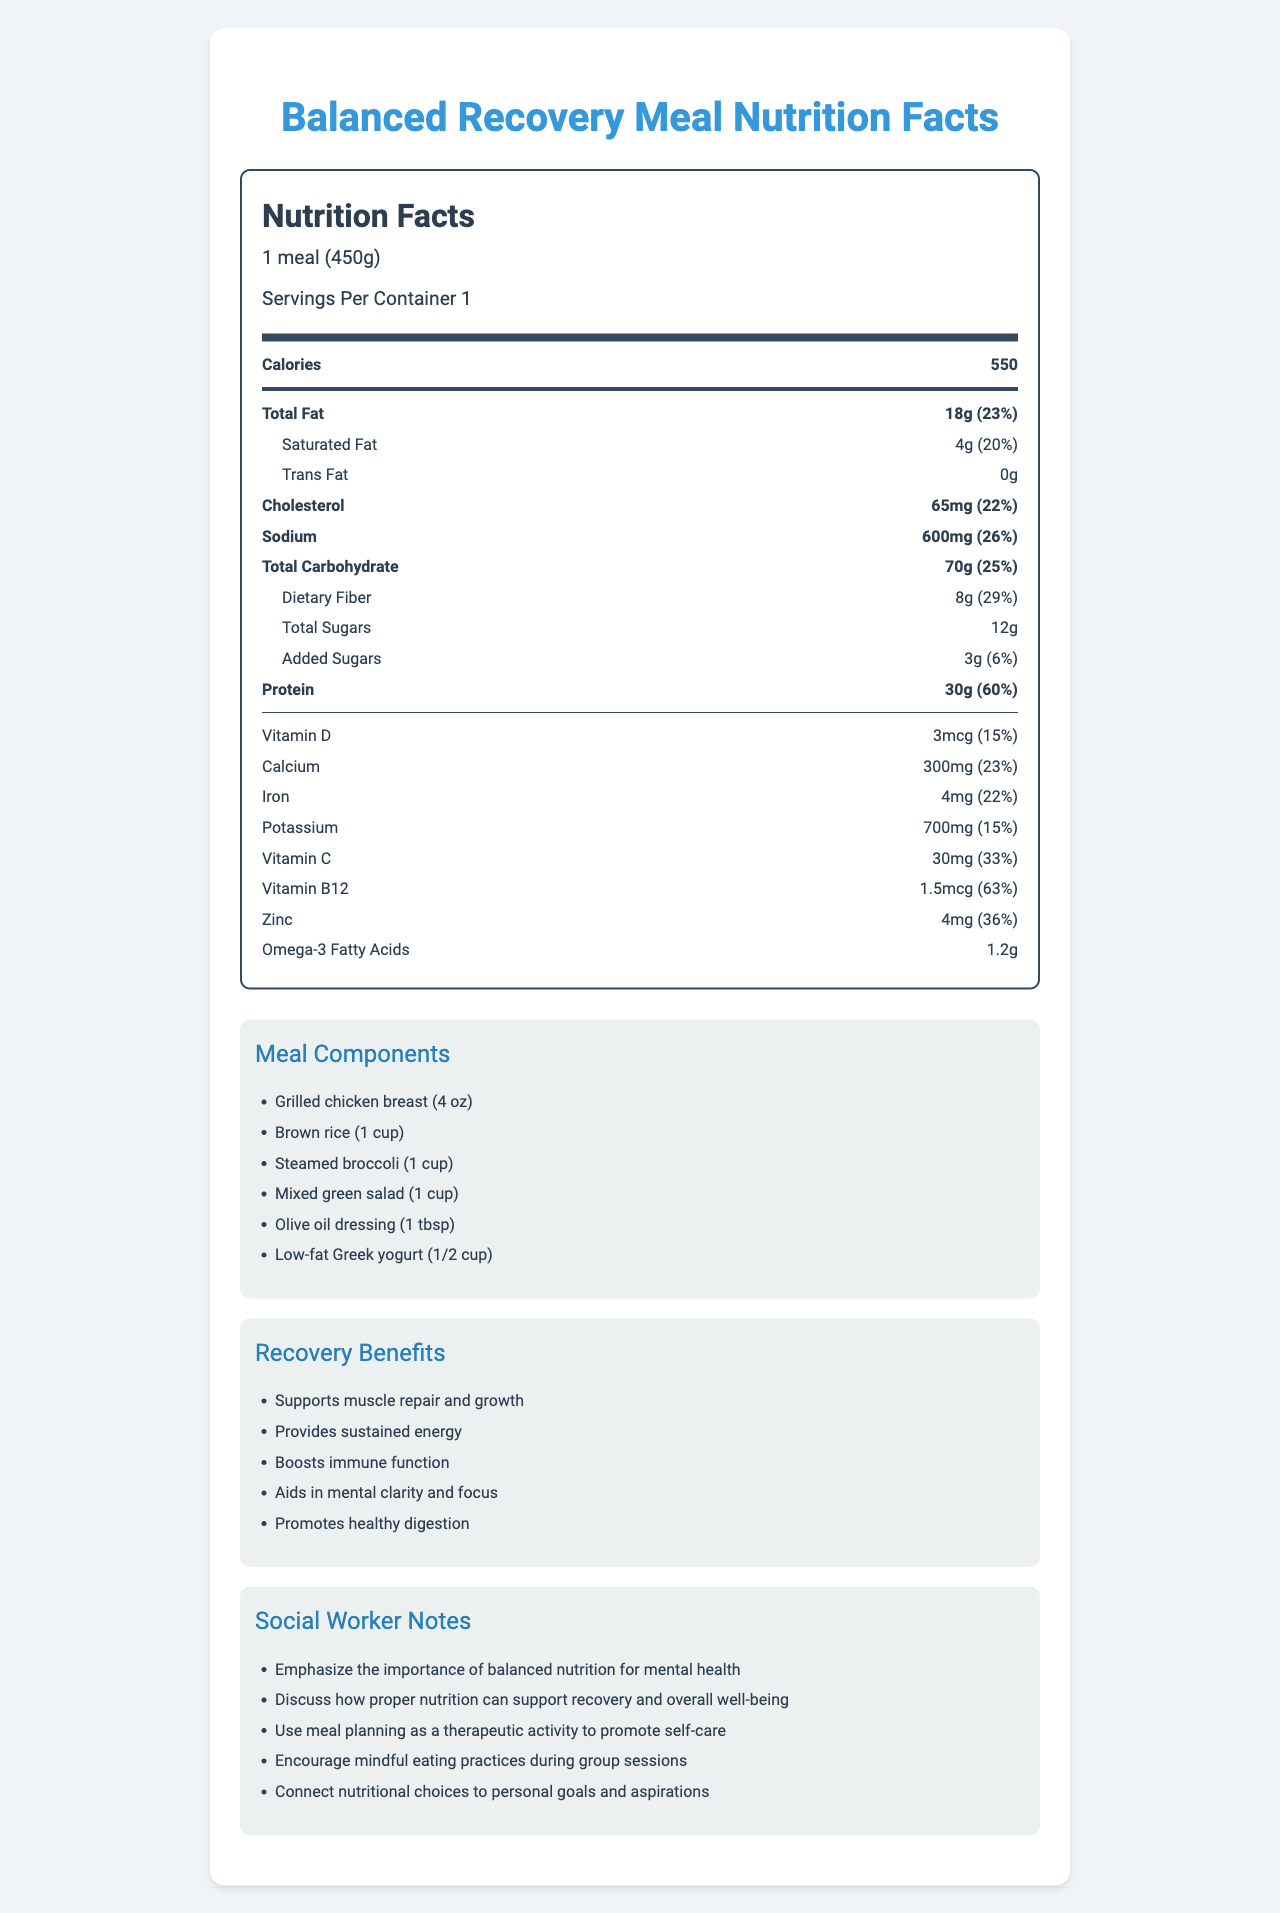what is the serving size for this balanced recovery meal? The serving size is listed at the top of the Nutrition Facts label.
Answer: 1 meal (450g) how many calories does one serving contain? The calories content is displayed right after the serving size information.
Answer: 550 what are the main benefits of this meal for recovery? The benefits are listed in the "Recovery Benefits" section at the bottom of the document.
Answer: Supports muscle repair and growth, Provides sustained energy, Boosts immune function, Aids in mental clarity and focus, Promotes healthy digestion what percentage of the daily value does protein fulfill? The percentage daily value for protein is given next to the protein amount in the Nutrition Facts section.
Answer: 60% how much dietary fiber is present and what percentage of the daily value does it represent? Both the amount (8g) and the percentage daily value (29%) are listed under the dietary fiber section.
Answer: 8g, 29% how many total sugars are there in this meal? The total sugars information is listed in the Nutrition Facts section.
Answer: 12g which of the following elements has the highest percent daily value: Vitamin C, Vitamin B12, or Zinc? A. Vitamin C B. Vitamin B12 C. Zinc Vitamin C is 33%, Vitamin B12 is 63%, and Zinc is 36%. Therefore, Vitamin B12 has the highest percent daily value.
Answer: B which component of the meal plan includes omega-3 fatty acids? A. Grilled chicken breast B. Brown rice C. Steamed broccoli D. Olive oil dressing E. Low-fat Greek yogurt Olive oil dressing is the component that typically contains omega-3 fatty acids.
Answer: D does this meal contain any trans fats? The document lists the amount of trans fats as 0g.
Answer: No what is the main purpose of the social worker notes? The main purpose can be found in the "Social Worker Notes" section.
Answer: To emphasize the importance of balanced nutrition for mental health, discuss how proper nutrition supports recovery and overall well-being, use meal planning as a therapeutic activity, encourage mindful eating practices, and connect nutritional choices to personal goals and aspirations were any additional vitamins or minerals added to the meal? The document does not specify whether additional vitamins or minerals were added to the meal; it only lists the amounts present.
Answer: Not enough information what does the document primarily describe? The document includes a detailed Nutrition Facts label, meal components, recovery benefits, and notes for social workers.
Answer: The document describes the nutritional facts for a balanced meal designed for adolescents in recovery, highlighting essential nutrients, meal components, and benefits for recovery. Additionally, it includes notes for social workers on using nutrition in therapeutic settings. 